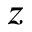<formula> <loc_0><loc_0><loc_500><loc_500>z</formula> 